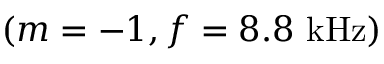Convert formula to latex. <formula><loc_0><loc_0><loc_500><loc_500>( m = - 1 , f = 8 . 8 \ k H z )</formula> 